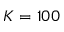Convert formula to latex. <formula><loc_0><loc_0><loc_500><loc_500>K = 1 0 0</formula> 